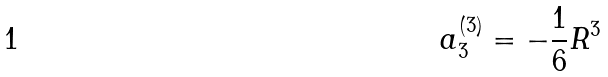Convert formula to latex. <formula><loc_0><loc_0><loc_500><loc_500>a _ { 3 } ^ { ( 3 ) } = - \frac { 1 } { 6 } R ^ { 3 }</formula> 